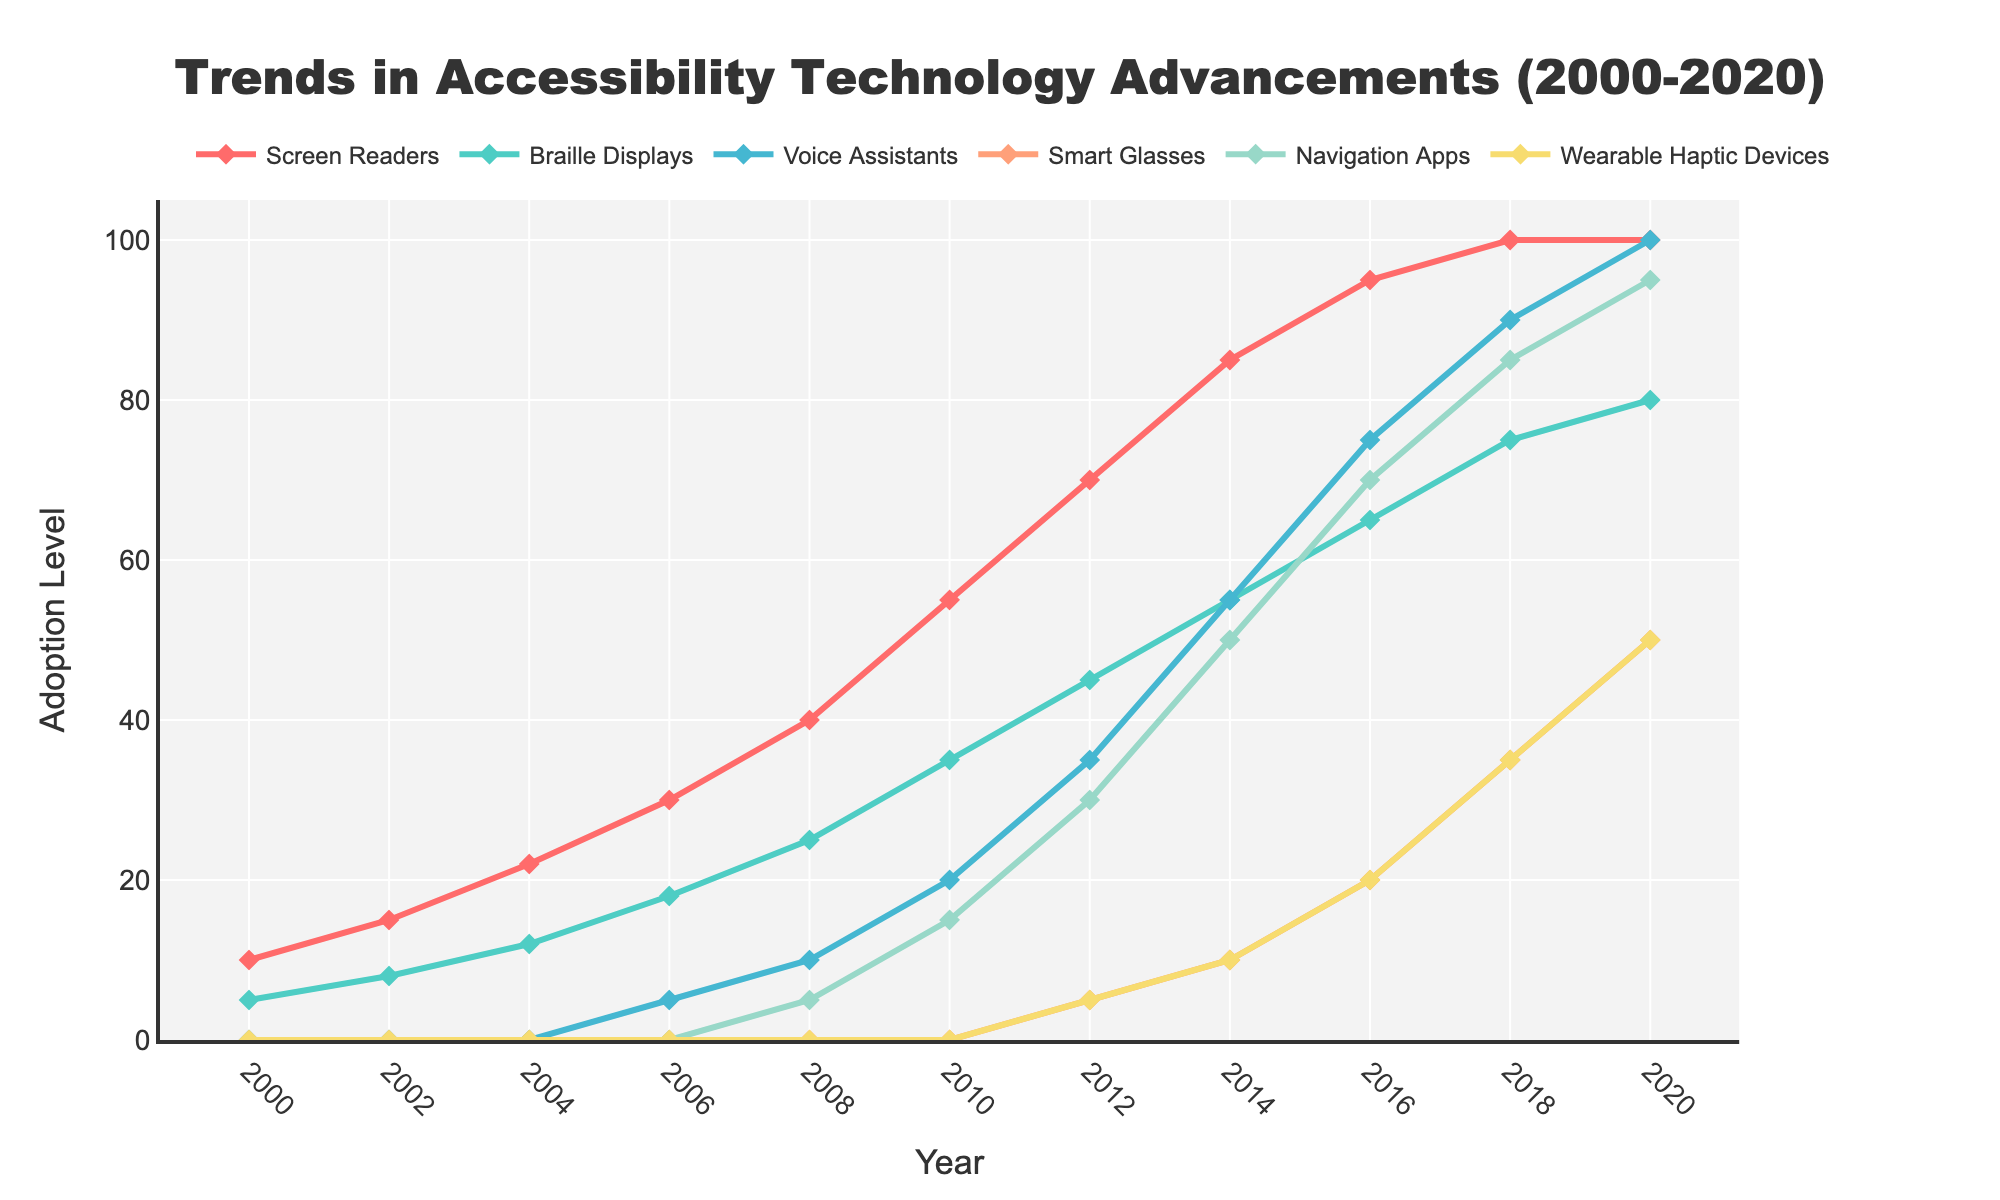What accessibility technology had the highest adoption level in 2020? Looking at the year 2020, identify the technology with the largest value on the y-axis. 'Voice Assistants' reaches the highest adoption level at 100.
Answer: Voice Assistants Between 2000 and 2010, which accessibility technology saw the greatest increase in adoption level? Subtract the adoption levels in 2000 from those in 2010 for each technology. The largest difference is seen in 'Screen Readers,' which increased from 10 to 55, a change of 45 units.
Answer: Screen Readers What is the combined adoption level for Smart Glasses and Navigation Apps in 2018? Look at the 2018 values for both 'Smart Glasses' and 'Navigation Apps' and sum them: 35 for Smart Glasses and 85 for Navigation Apps. 35 + 85 = 120.
Answer: 120 Which technology reached a 50% adoption level first, and in what year? Identify the first y-value where each technology hits 50 or more. 'Screen Readers' reached 50% in 2008, while other technologies reached this level later.
Answer: Screen Readers, 2008 Compare the adoption growth of Braille Displays and Wearable Haptic Devices between 2010 and 2020. Which one grew more, and by how much? Calculate the differences for both technologies from 2010 to 2020. Braille Displays: 80 - 35 = 45; Wearable Haptic Devices: 50 - 0 = 50. Wearable Haptic Devices grew more by 5 units.
Answer: Wearable Haptic Devices, 5 How did the adoption levels for Navigation Apps change from 2008 to 2016? Check the values for 'Navigation Apps' in 2008 and 2016. In 2008 it was 5, and in 2016 it was 70. The change is 70 - 5 = 65.
Answer: Increased by 65 In which year did Voice Assistants first appear, and what was their adoption level that year? Identify the first non-zero value for 'Voice Assistants.' It first appears in 2006 with an adoption level of 5.
Answer: 2006, 5 How many years did it take for Wearable Haptic Devices to reach an adoption level of 20 after their introduction? Wearable Haptic Devices first appear in 2012 at level 5 and reached 20 in 2016. The difference in years is 2016 - 2012 = 4 years.
Answer: 4 Which two technologies had the closest adoption levels in 2014, and what were their values? In 2014, compare the adoption levels. 'Smart Glasses' at 10 and 'Wearable Haptic Devices' at 10.
Answer: Smart Glasses and Wearable Haptic Devices, 10 